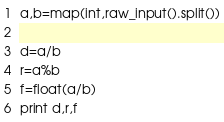<code> <loc_0><loc_0><loc_500><loc_500><_Python_>a,b=map(int,raw_input().split())

d=a/b
r=a%b
f=float(a/b)
print d,r,f</code> 